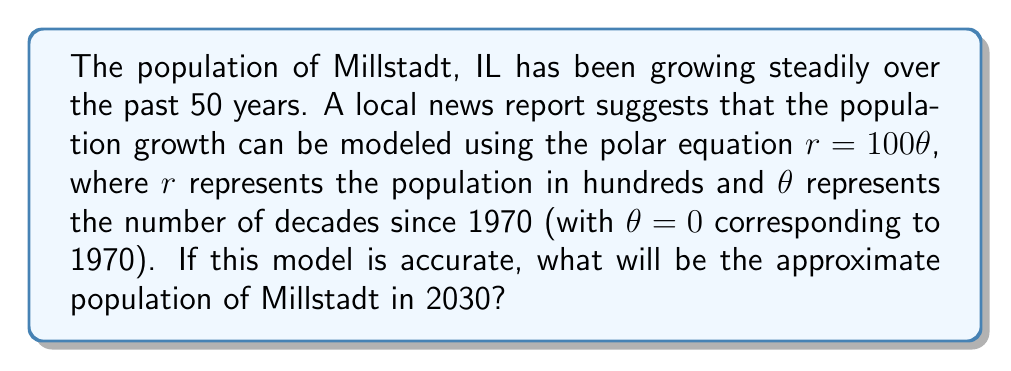What is the answer to this math problem? To solve this problem, we need to follow these steps:

1) First, we need to determine the value of $\theta$ for the year 2030:
   - 1970 corresponds to $\theta = 0$
   - Each decade increases $\theta$ by 1
   - From 1970 to 2030 is 6 decades
   - Therefore, $\theta = 6$ for 2030

2) Now we can use the given polar equation to calculate $r$:
   $r = 100\theta$
   $r = 100 \cdot 6 = 600$

3) Remember that $r$ represents the population in hundreds. So we need to multiply by 100 to get the actual population:
   Population = $600 \cdot 100 = 60,000$

4) It's important to note that this is an approximation based on the given model. Real population growth is often more complex and may not follow such a simple linear pattern.

[asy]
import graph;
size(200);
real f(real t) {return 100*t;}
draw(polargraph(f,0,6,operator ..),Arrow);
xaxis("$x$",Arrow);
yaxis("$y$",Arrow);
label("$\theta=1$", (100,0), E);
label("$\theta=2$", (200,0), E);
label("$\theta=3$", (300,0), E);
label("$\theta=4$", (400,0), E);
label("$\theta=5$", (500,0), E);
label("$\theta=6$", (600,0), E);
[/asy]

The graph shows how the population (represented by the distance from the origin) increases linearly with each decade (represented by the angle).
Answer: The approximate population of Millstadt in 2030 will be 60,000 people. 